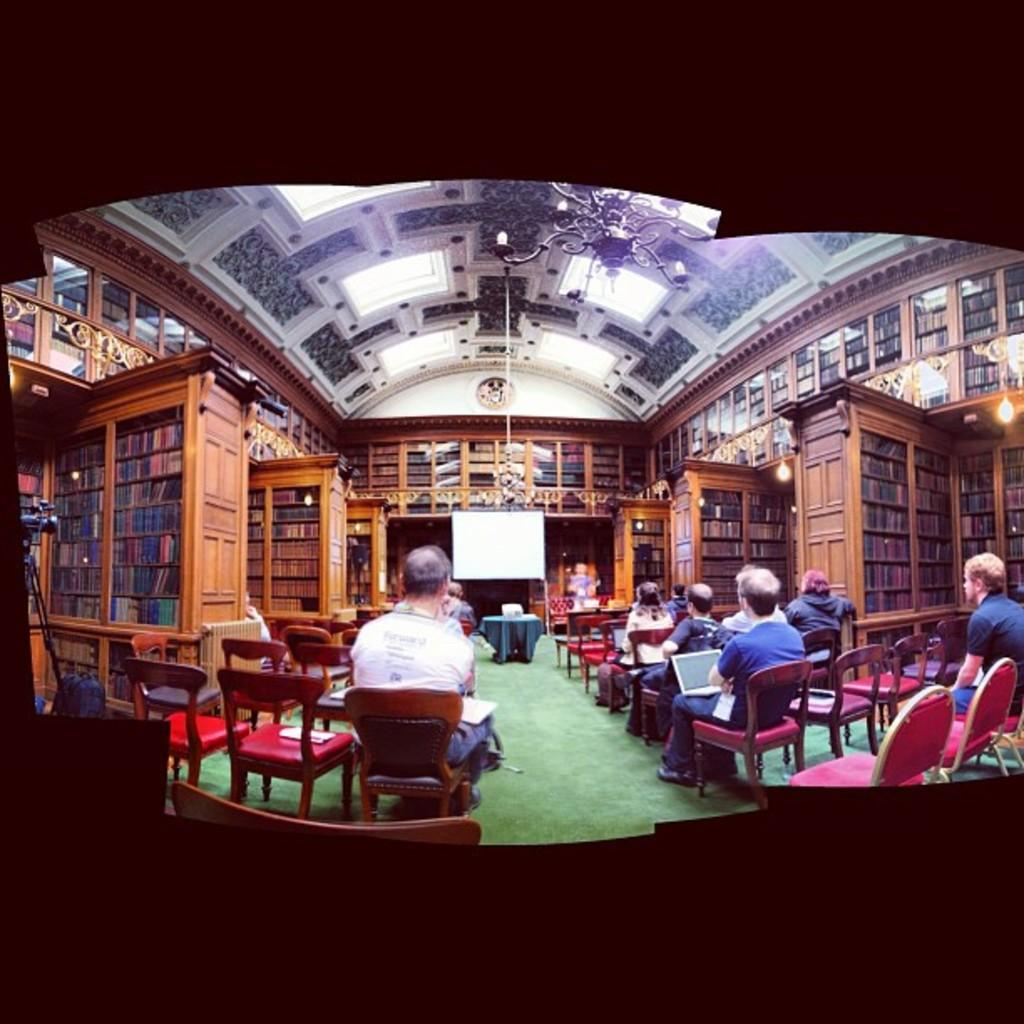What are the people in the image doing? The persons in the image are sitting on chairs. What is present on the floor in the image? There is a table in the image. What is the board used for in the image? The board is present in the image, but its purpose is not clear from the facts provided. What can be seen in the background of the image? There are racks in the background of the image. What is above the people in the image? There is a roof in the image. How many letters are being controlled by the person in the image? There is no mention of letters or any control mechanism in the image. What type of selection process is being conducted in the image? There is no indication of a selection process in the image. 